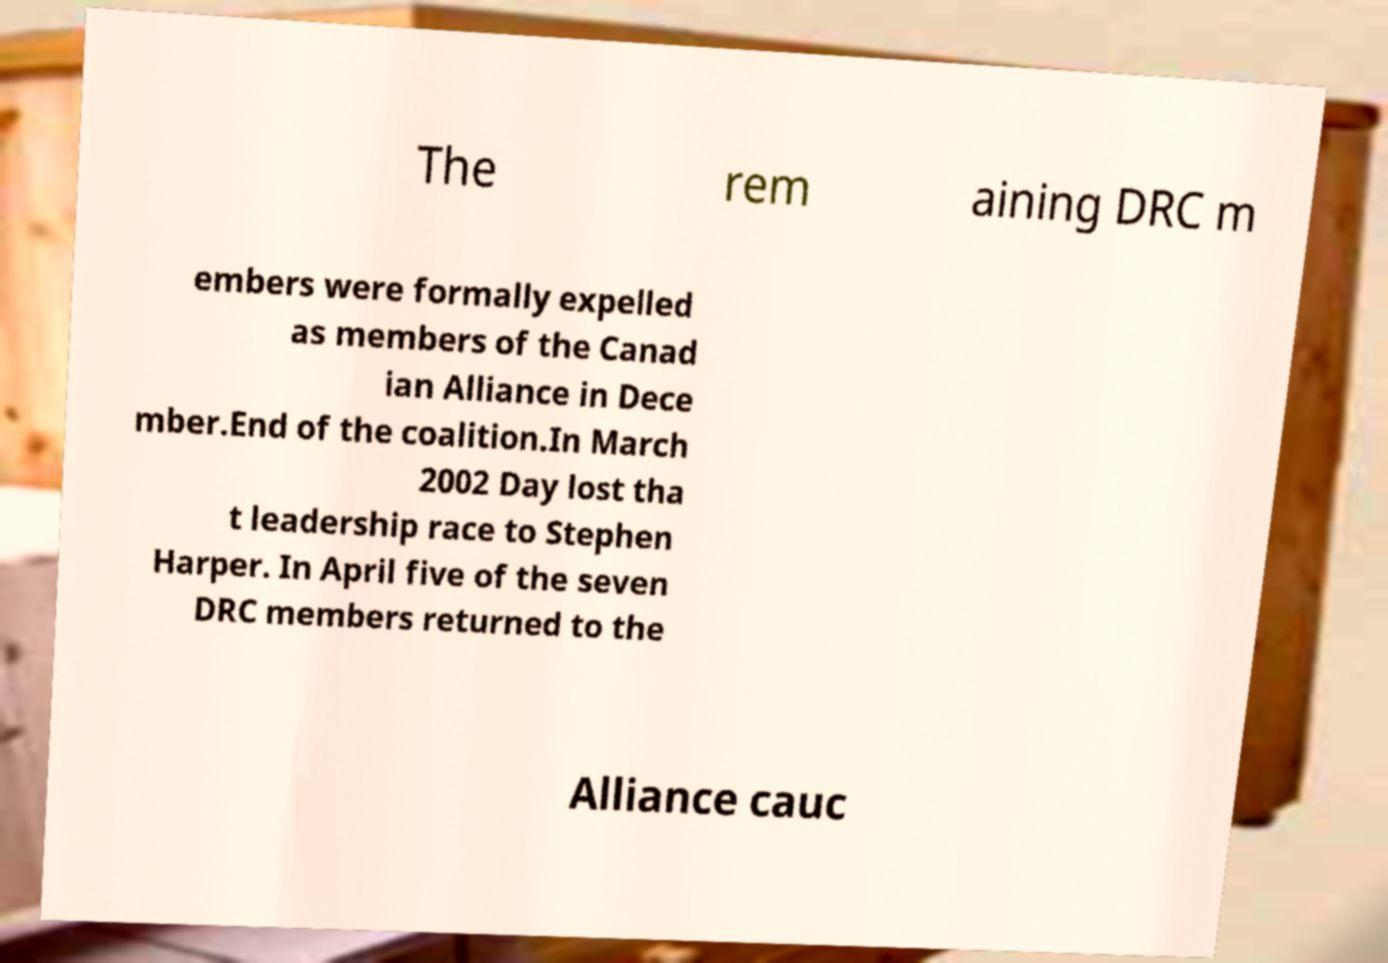Could you extract and type out the text from this image? The rem aining DRC m embers were formally expelled as members of the Canad ian Alliance in Dece mber.End of the coalition.In March 2002 Day lost tha t leadership race to Stephen Harper. In April five of the seven DRC members returned to the Alliance cauc 